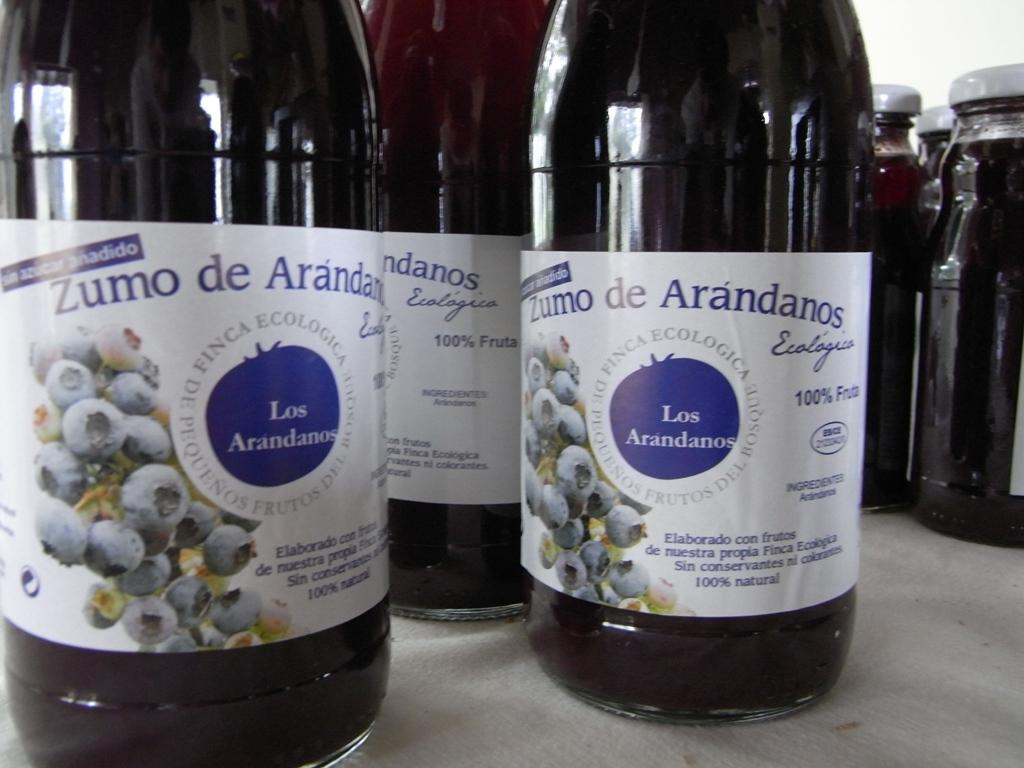<image>
Give a short and clear explanation of the subsequent image. Several bottles that say Zumo de Arandanos also have blueberries on the label. 